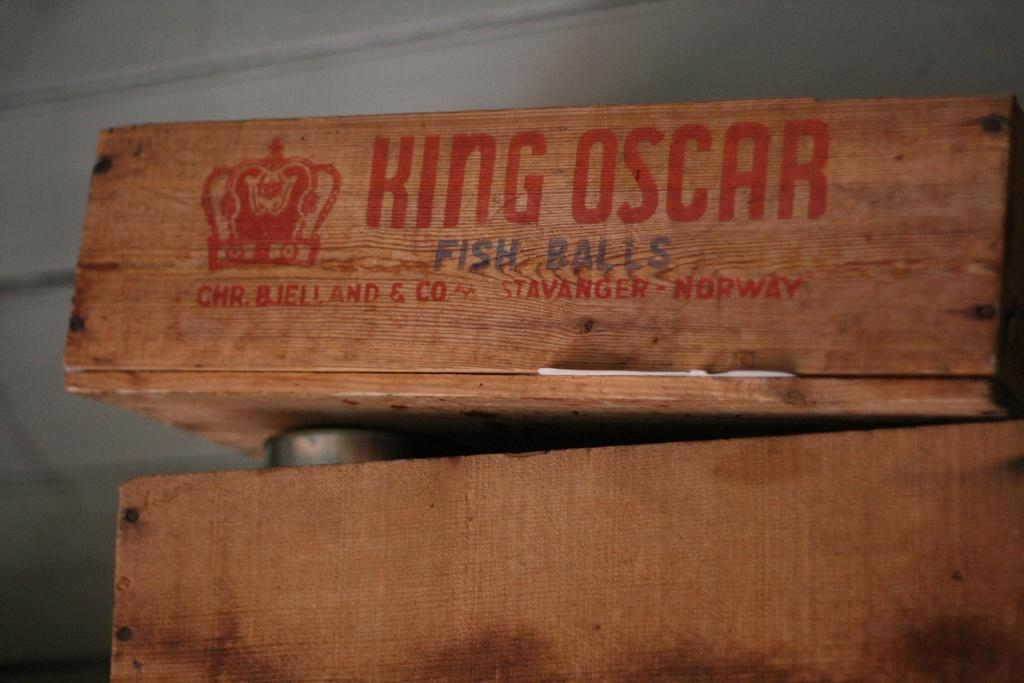What object is the main focus of the image? There is a wooden box in the image. What is written or depicted on the wooden box? There is text written on the wooden box. What can be seen in the background of the image? There is a wall in the background of the image. What color is the wall in the image? The wall is white in color. What type of plastic board is being used to create a shock in the image? There is no plastic board or shock present in the image; it features a wooden box with text and a white wall in the background. 